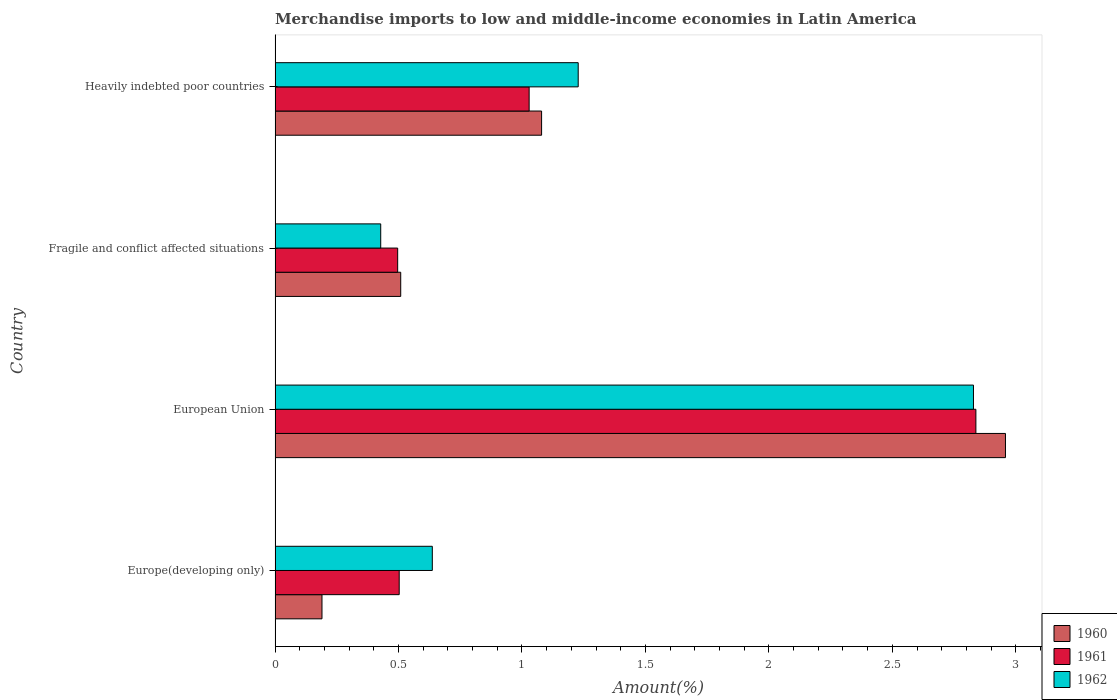How many groups of bars are there?
Your answer should be very brief. 4. Are the number of bars per tick equal to the number of legend labels?
Your response must be concise. Yes. How many bars are there on the 3rd tick from the top?
Provide a succinct answer. 3. How many bars are there on the 1st tick from the bottom?
Offer a terse response. 3. What is the label of the 3rd group of bars from the top?
Ensure brevity in your answer.  European Union. In how many cases, is the number of bars for a given country not equal to the number of legend labels?
Ensure brevity in your answer.  0. What is the percentage of amount earned from merchandise imports in 1960 in Heavily indebted poor countries?
Ensure brevity in your answer.  1.08. Across all countries, what is the maximum percentage of amount earned from merchandise imports in 1961?
Your response must be concise. 2.84. Across all countries, what is the minimum percentage of amount earned from merchandise imports in 1961?
Offer a terse response. 0.5. In which country was the percentage of amount earned from merchandise imports in 1960 minimum?
Provide a succinct answer. Europe(developing only). What is the total percentage of amount earned from merchandise imports in 1960 in the graph?
Your answer should be compact. 4.74. What is the difference between the percentage of amount earned from merchandise imports in 1960 in Europe(developing only) and that in European Union?
Ensure brevity in your answer.  -2.77. What is the difference between the percentage of amount earned from merchandise imports in 1961 in Europe(developing only) and the percentage of amount earned from merchandise imports in 1960 in Fragile and conflict affected situations?
Your answer should be compact. -0.01. What is the average percentage of amount earned from merchandise imports in 1961 per country?
Your answer should be very brief. 1.22. What is the difference between the percentage of amount earned from merchandise imports in 1962 and percentage of amount earned from merchandise imports in 1961 in Heavily indebted poor countries?
Your response must be concise. 0.2. What is the ratio of the percentage of amount earned from merchandise imports in 1962 in Europe(developing only) to that in Heavily indebted poor countries?
Provide a short and direct response. 0.52. Is the percentage of amount earned from merchandise imports in 1961 in European Union less than that in Heavily indebted poor countries?
Your answer should be compact. No. What is the difference between the highest and the second highest percentage of amount earned from merchandise imports in 1960?
Give a very brief answer. 1.88. What is the difference between the highest and the lowest percentage of amount earned from merchandise imports in 1960?
Provide a succinct answer. 2.77. In how many countries, is the percentage of amount earned from merchandise imports in 1960 greater than the average percentage of amount earned from merchandise imports in 1960 taken over all countries?
Make the answer very short. 1. Are the values on the major ticks of X-axis written in scientific E-notation?
Give a very brief answer. No. Does the graph contain any zero values?
Your answer should be compact. No. Where does the legend appear in the graph?
Provide a short and direct response. Bottom right. How many legend labels are there?
Provide a succinct answer. 3. What is the title of the graph?
Your answer should be very brief. Merchandise imports to low and middle-income economies in Latin America. Does "1970" appear as one of the legend labels in the graph?
Ensure brevity in your answer.  No. What is the label or title of the X-axis?
Ensure brevity in your answer.  Amount(%). What is the label or title of the Y-axis?
Offer a terse response. Country. What is the Amount(%) of 1960 in Europe(developing only)?
Offer a very short reply. 0.19. What is the Amount(%) of 1961 in Europe(developing only)?
Provide a succinct answer. 0.5. What is the Amount(%) of 1962 in Europe(developing only)?
Keep it short and to the point. 0.64. What is the Amount(%) in 1960 in European Union?
Your answer should be very brief. 2.96. What is the Amount(%) of 1961 in European Union?
Your answer should be very brief. 2.84. What is the Amount(%) in 1962 in European Union?
Keep it short and to the point. 2.83. What is the Amount(%) in 1960 in Fragile and conflict affected situations?
Your answer should be very brief. 0.51. What is the Amount(%) in 1961 in Fragile and conflict affected situations?
Offer a very short reply. 0.5. What is the Amount(%) in 1962 in Fragile and conflict affected situations?
Give a very brief answer. 0.43. What is the Amount(%) of 1960 in Heavily indebted poor countries?
Give a very brief answer. 1.08. What is the Amount(%) in 1961 in Heavily indebted poor countries?
Your answer should be very brief. 1.03. What is the Amount(%) of 1962 in Heavily indebted poor countries?
Offer a very short reply. 1.23. Across all countries, what is the maximum Amount(%) of 1960?
Your answer should be compact. 2.96. Across all countries, what is the maximum Amount(%) of 1961?
Offer a terse response. 2.84. Across all countries, what is the maximum Amount(%) in 1962?
Your response must be concise. 2.83. Across all countries, what is the minimum Amount(%) in 1960?
Your answer should be very brief. 0.19. Across all countries, what is the minimum Amount(%) in 1961?
Offer a very short reply. 0.5. Across all countries, what is the minimum Amount(%) of 1962?
Your answer should be compact. 0.43. What is the total Amount(%) of 1960 in the graph?
Your answer should be very brief. 4.74. What is the total Amount(%) in 1961 in the graph?
Keep it short and to the point. 4.87. What is the total Amount(%) in 1962 in the graph?
Your answer should be very brief. 5.12. What is the difference between the Amount(%) of 1960 in Europe(developing only) and that in European Union?
Give a very brief answer. -2.77. What is the difference between the Amount(%) in 1961 in Europe(developing only) and that in European Union?
Provide a succinct answer. -2.34. What is the difference between the Amount(%) in 1962 in Europe(developing only) and that in European Union?
Your response must be concise. -2.19. What is the difference between the Amount(%) in 1960 in Europe(developing only) and that in Fragile and conflict affected situations?
Offer a very short reply. -0.32. What is the difference between the Amount(%) of 1961 in Europe(developing only) and that in Fragile and conflict affected situations?
Provide a short and direct response. 0.01. What is the difference between the Amount(%) in 1962 in Europe(developing only) and that in Fragile and conflict affected situations?
Your response must be concise. 0.21. What is the difference between the Amount(%) in 1960 in Europe(developing only) and that in Heavily indebted poor countries?
Keep it short and to the point. -0.89. What is the difference between the Amount(%) of 1961 in Europe(developing only) and that in Heavily indebted poor countries?
Make the answer very short. -0.53. What is the difference between the Amount(%) in 1962 in Europe(developing only) and that in Heavily indebted poor countries?
Make the answer very short. -0.59. What is the difference between the Amount(%) of 1960 in European Union and that in Fragile and conflict affected situations?
Offer a terse response. 2.45. What is the difference between the Amount(%) in 1961 in European Union and that in Fragile and conflict affected situations?
Provide a short and direct response. 2.34. What is the difference between the Amount(%) in 1962 in European Union and that in Fragile and conflict affected situations?
Your answer should be very brief. 2.4. What is the difference between the Amount(%) in 1960 in European Union and that in Heavily indebted poor countries?
Offer a very short reply. 1.88. What is the difference between the Amount(%) in 1961 in European Union and that in Heavily indebted poor countries?
Your response must be concise. 1.81. What is the difference between the Amount(%) of 1962 in European Union and that in Heavily indebted poor countries?
Keep it short and to the point. 1.6. What is the difference between the Amount(%) in 1960 in Fragile and conflict affected situations and that in Heavily indebted poor countries?
Offer a terse response. -0.57. What is the difference between the Amount(%) in 1961 in Fragile and conflict affected situations and that in Heavily indebted poor countries?
Your answer should be compact. -0.53. What is the difference between the Amount(%) in 1962 in Fragile and conflict affected situations and that in Heavily indebted poor countries?
Your answer should be very brief. -0.8. What is the difference between the Amount(%) in 1960 in Europe(developing only) and the Amount(%) in 1961 in European Union?
Your answer should be compact. -2.65. What is the difference between the Amount(%) in 1960 in Europe(developing only) and the Amount(%) in 1962 in European Union?
Give a very brief answer. -2.64. What is the difference between the Amount(%) of 1961 in Europe(developing only) and the Amount(%) of 1962 in European Union?
Your answer should be very brief. -2.33. What is the difference between the Amount(%) of 1960 in Europe(developing only) and the Amount(%) of 1961 in Fragile and conflict affected situations?
Keep it short and to the point. -0.31. What is the difference between the Amount(%) in 1960 in Europe(developing only) and the Amount(%) in 1962 in Fragile and conflict affected situations?
Keep it short and to the point. -0.24. What is the difference between the Amount(%) of 1961 in Europe(developing only) and the Amount(%) of 1962 in Fragile and conflict affected situations?
Provide a succinct answer. 0.07. What is the difference between the Amount(%) in 1960 in Europe(developing only) and the Amount(%) in 1961 in Heavily indebted poor countries?
Ensure brevity in your answer.  -0.84. What is the difference between the Amount(%) in 1960 in Europe(developing only) and the Amount(%) in 1962 in Heavily indebted poor countries?
Your answer should be very brief. -1.04. What is the difference between the Amount(%) in 1961 in Europe(developing only) and the Amount(%) in 1962 in Heavily indebted poor countries?
Offer a terse response. -0.72. What is the difference between the Amount(%) in 1960 in European Union and the Amount(%) in 1961 in Fragile and conflict affected situations?
Your answer should be compact. 2.46. What is the difference between the Amount(%) in 1960 in European Union and the Amount(%) in 1962 in Fragile and conflict affected situations?
Your response must be concise. 2.53. What is the difference between the Amount(%) of 1961 in European Union and the Amount(%) of 1962 in Fragile and conflict affected situations?
Offer a very short reply. 2.41. What is the difference between the Amount(%) of 1960 in European Union and the Amount(%) of 1961 in Heavily indebted poor countries?
Offer a very short reply. 1.93. What is the difference between the Amount(%) of 1960 in European Union and the Amount(%) of 1962 in Heavily indebted poor countries?
Your answer should be compact. 1.73. What is the difference between the Amount(%) of 1961 in European Union and the Amount(%) of 1962 in Heavily indebted poor countries?
Ensure brevity in your answer.  1.61. What is the difference between the Amount(%) in 1960 in Fragile and conflict affected situations and the Amount(%) in 1961 in Heavily indebted poor countries?
Offer a very short reply. -0.52. What is the difference between the Amount(%) in 1960 in Fragile and conflict affected situations and the Amount(%) in 1962 in Heavily indebted poor countries?
Provide a short and direct response. -0.72. What is the difference between the Amount(%) in 1961 in Fragile and conflict affected situations and the Amount(%) in 1962 in Heavily indebted poor countries?
Provide a short and direct response. -0.73. What is the average Amount(%) of 1960 per country?
Make the answer very short. 1.18. What is the average Amount(%) of 1961 per country?
Provide a succinct answer. 1.22. What is the average Amount(%) of 1962 per country?
Ensure brevity in your answer.  1.28. What is the difference between the Amount(%) of 1960 and Amount(%) of 1961 in Europe(developing only)?
Offer a very short reply. -0.31. What is the difference between the Amount(%) in 1960 and Amount(%) in 1962 in Europe(developing only)?
Offer a terse response. -0.45. What is the difference between the Amount(%) in 1961 and Amount(%) in 1962 in Europe(developing only)?
Ensure brevity in your answer.  -0.13. What is the difference between the Amount(%) in 1960 and Amount(%) in 1961 in European Union?
Offer a very short reply. 0.12. What is the difference between the Amount(%) of 1960 and Amount(%) of 1962 in European Union?
Your response must be concise. 0.13. What is the difference between the Amount(%) of 1961 and Amount(%) of 1962 in European Union?
Keep it short and to the point. 0.01. What is the difference between the Amount(%) in 1960 and Amount(%) in 1961 in Fragile and conflict affected situations?
Offer a very short reply. 0.01. What is the difference between the Amount(%) in 1960 and Amount(%) in 1962 in Fragile and conflict affected situations?
Provide a short and direct response. 0.08. What is the difference between the Amount(%) in 1961 and Amount(%) in 1962 in Fragile and conflict affected situations?
Your answer should be very brief. 0.07. What is the difference between the Amount(%) in 1960 and Amount(%) in 1961 in Heavily indebted poor countries?
Offer a terse response. 0.05. What is the difference between the Amount(%) in 1960 and Amount(%) in 1962 in Heavily indebted poor countries?
Your answer should be very brief. -0.15. What is the difference between the Amount(%) in 1961 and Amount(%) in 1962 in Heavily indebted poor countries?
Offer a terse response. -0.2. What is the ratio of the Amount(%) in 1960 in Europe(developing only) to that in European Union?
Your response must be concise. 0.06. What is the ratio of the Amount(%) in 1961 in Europe(developing only) to that in European Union?
Give a very brief answer. 0.18. What is the ratio of the Amount(%) of 1962 in Europe(developing only) to that in European Union?
Offer a terse response. 0.23. What is the ratio of the Amount(%) in 1960 in Europe(developing only) to that in Fragile and conflict affected situations?
Your response must be concise. 0.37. What is the ratio of the Amount(%) in 1961 in Europe(developing only) to that in Fragile and conflict affected situations?
Your answer should be compact. 1.01. What is the ratio of the Amount(%) in 1962 in Europe(developing only) to that in Fragile and conflict affected situations?
Provide a short and direct response. 1.49. What is the ratio of the Amount(%) of 1960 in Europe(developing only) to that in Heavily indebted poor countries?
Offer a terse response. 0.18. What is the ratio of the Amount(%) in 1961 in Europe(developing only) to that in Heavily indebted poor countries?
Provide a succinct answer. 0.49. What is the ratio of the Amount(%) in 1962 in Europe(developing only) to that in Heavily indebted poor countries?
Your answer should be very brief. 0.52. What is the ratio of the Amount(%) of 1960 in European Union to that in Fragile and conflict affected situations?
Provide a succinct answer. 5.81. What is the ratio of the Amount(%) of 1961 in European Union to that in Fragile and conflict affected situations?
Your answer should be compact. 5.72. What is the ratio of the Amount(%) of 1962 in European Union to that in Fragile and conflict affected situations?
Your answer should be very brief. 6.61. What is the ratio of the Amount(%) in 1960 in European Union to that in Heavily indebted poor countries?
Your response must be concise. 2.74. What is the ratio of the Amount(%) in 1961 in European Union to that in Heavily indebted poor countries?
Provide a succinct answer. 2.76. What is the ratio of the Amount(%) in 1962 in European Union to that in Heavily indebted poor countries?
Offer a terse response. 2.3. What is the ratio of the Amount(%) in 1960 in Fragile and conflict affected situations to that in Heavily indebted poor countries?
Keep it short and to the point. 0.47. What is the ratio of the Amount(%) in 1961 in Fragile and conflict affected situations to that in Heavily indebted poor countries?
Provide a succinct answer. 0.48. What is the ratio of the Amount(%) in 1962 in Fragile and conflict affected situations to that in Heavily indebted poor countries?
Your answer should be compact. 0.35. What is the difference between the highest and the second highest Amount(%) in 1960?
Your response must be concise. 1.88. What is the difference between the highest and the second highest Amount(%) of 1961?
Your answer should be compact. 1.81. What is the difference between the highest and the second highest Amount(%) of 1962?
Make the answer very short. 1.6. What is the difference between the highest and the lowest Amount(%) of 1960?
Give a very brief answer. 2.77. What is the difference between the highest and the lowest Amount(%) in 1961?
Your answer should be compact. 2.34. What is the difference between the highest and the lowest Amount(%) of 1962?
Offer a very short reply. 2.4. 